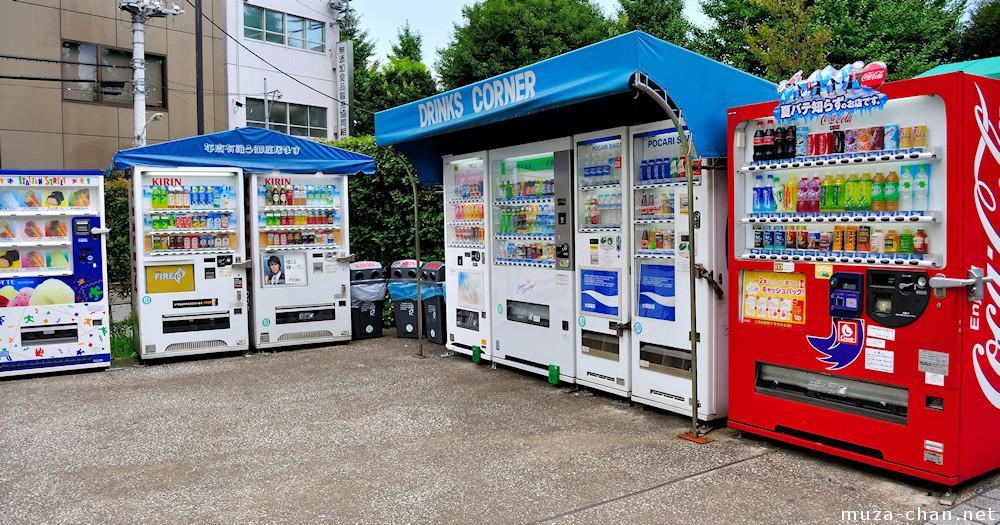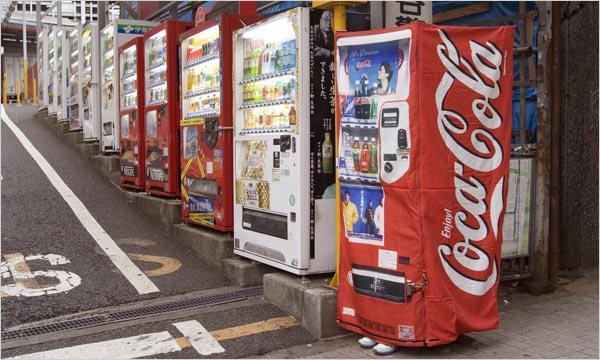The first image is the image on the left, the second image is the image on the right. Analyze the images presented: Is the assertion "In the right image, there is no less than one person standing in front of and staring ahead at a row of vending machines" valid? Answer yes or no. No. The first image is the image on the left, the second image is the image on the right. Considering the images on both sides, is "At least one person is near the machines in the image on the right." valid? Answer yes or no. No. 